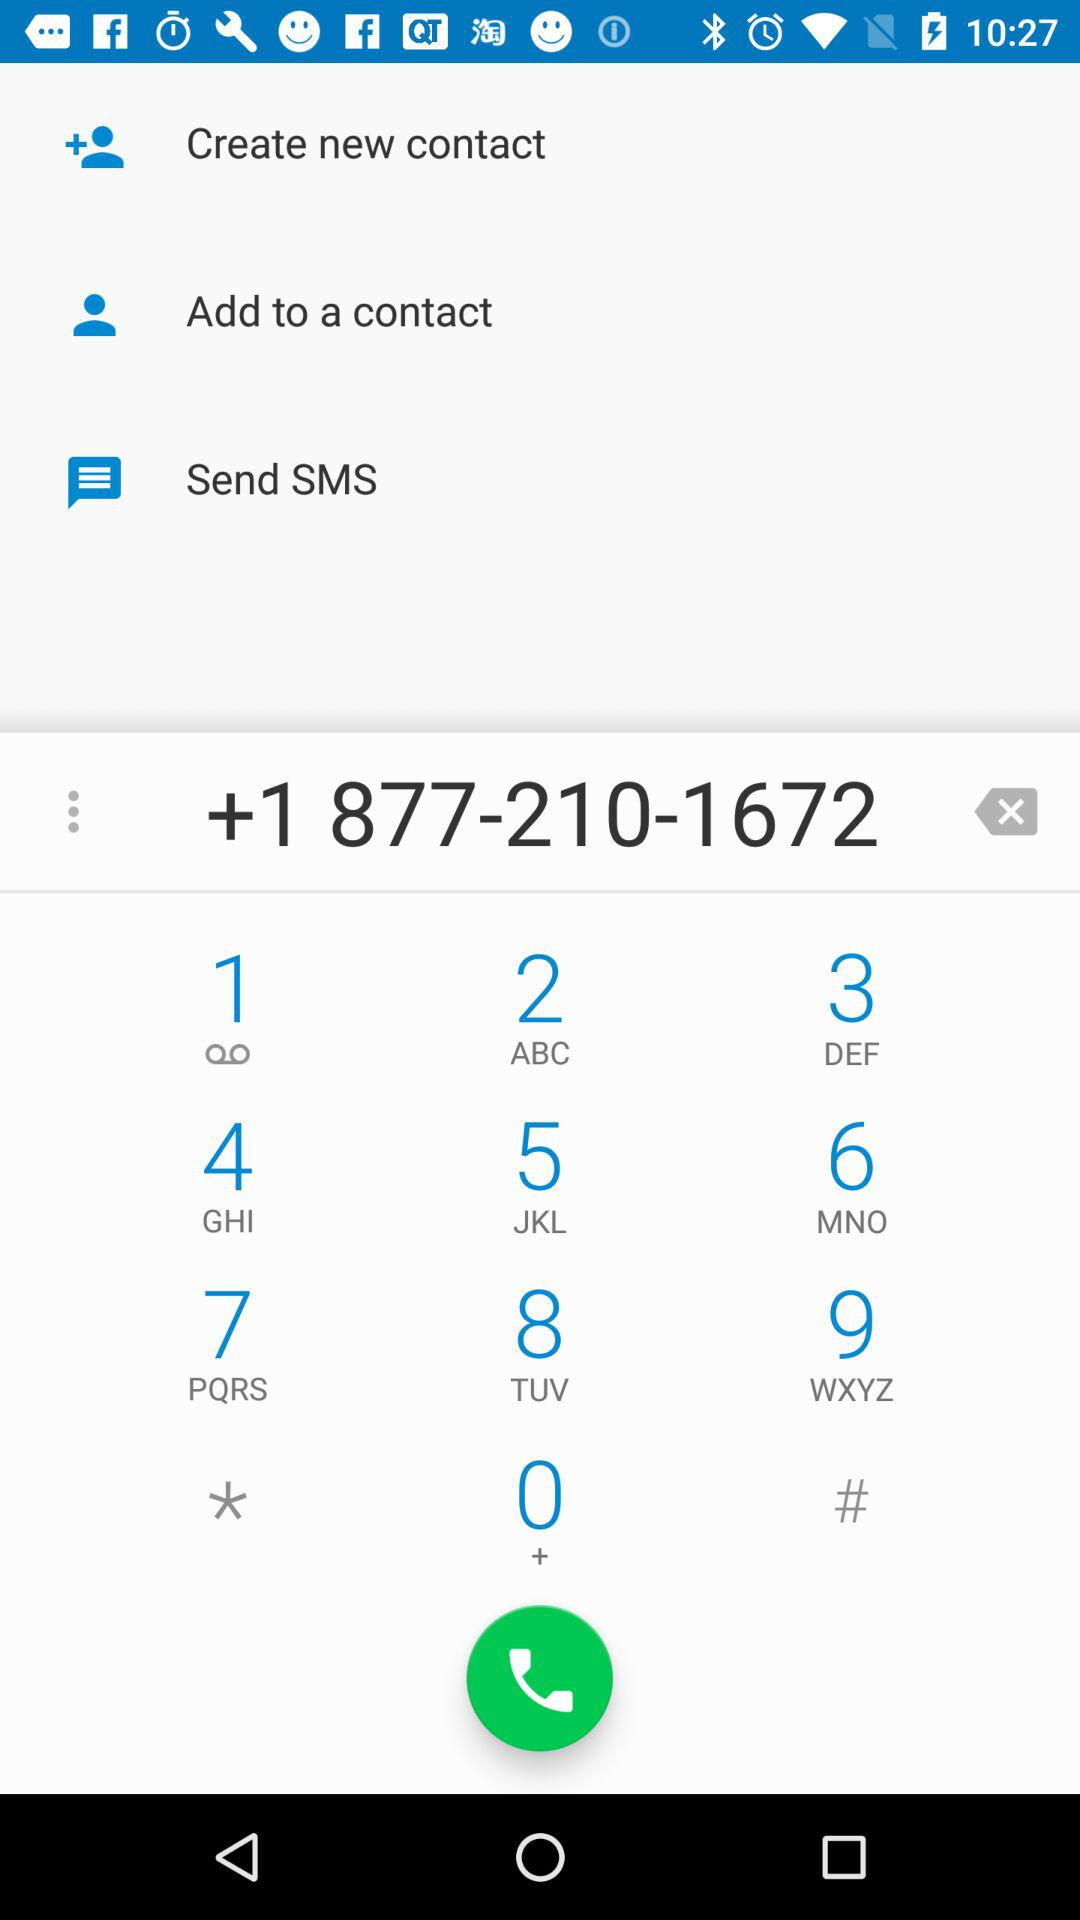How many options are there to communicate with this number?
Answer the question using a single word or phrase. 3 